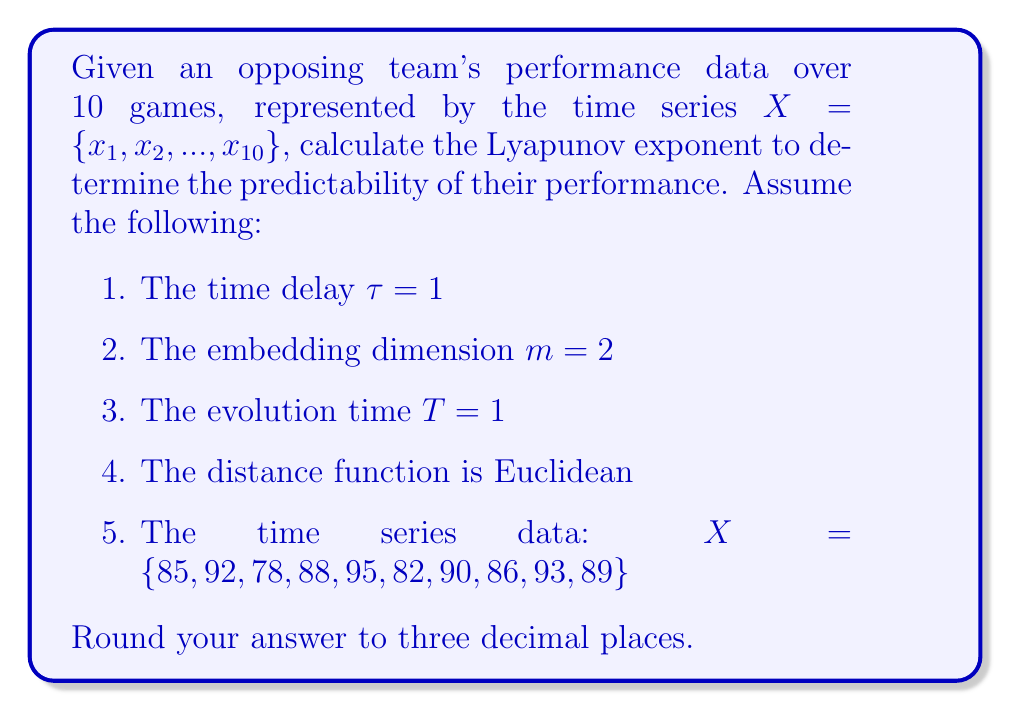What is the answer to this math problem? To calculate the Lyapunov exponent for this time series:

1. Construct the phase space vectors:
   $Y_1 = (85, 92)$, $Y_2 = (92, 78)$, $Y_3 = (78, 88)$, ..., $Y_9 = (93, 89)$

2. For each vector $Y_i$, find its nearest neighbor $Y_j$ (excluding adjacent points):
   Calculate distances and find minimum for each $i$.

3. Calculate the distance between each pair after one time step:
   $d_0 = ||Y_i - Y_j||$
   $d_1 = ||Y_{i+1} - Y_{j+1}||$

4. Calculate $\ln(\frac{d_1}{d_0})$ for each pair.

5. The Lyapunov exponent $\lambda$ is the average of these values:

   $$\lambda = \frac{1}{N-1} \sum_{i=1}^{N-1} \ln(\frac{d_1}{d_0})$$

   where $N$ is the number of valid vector pairs.

Calculating for each pair:

1. $Y_1$ and $Y_7$: $\ln(\frac{||Y_2 - Y_8||}{||Y_1 - Y_7||}) = \ln(\frac{14.142}{5}) = 1.040$
2. $Y_2$ and $Y_8$: $\ln(\frac{||Y_3 - Y_9||}{||Y_2 - Y_8||}) = \ln(\frac{15.811}{14.142}) = 0.112$
3. $Y_3$ and $Y_5$: $\ln(\frac{||Y_4 - Y_6||}{||Y_3 - Y_5||}) = \ln(\frac{6}{17}) = -1.041$
4. $Y_4$ and $Y_6$: $\ln(\frac{||Y_5 - Y_7||}{||Y_4 - Y_6||}) = \ln(\frac{5.831}{6}) = -0.029$
5. $Y_5$ and $Y_9$: $\ln(\frac{||Y_6 - Y_{10}||}{||Y_5 - Y_9||}) = \ln(\frac{7.071}{4.472}) = 0.458$

Average these values:
$$\lambda = \frac{1.040 + 0.112 - 1.041 - 0.029 + 0.458}{5} = 0.108$$

Rounding to three decimal places: $\lambda \approx 0.108$
Answer: 0.108 